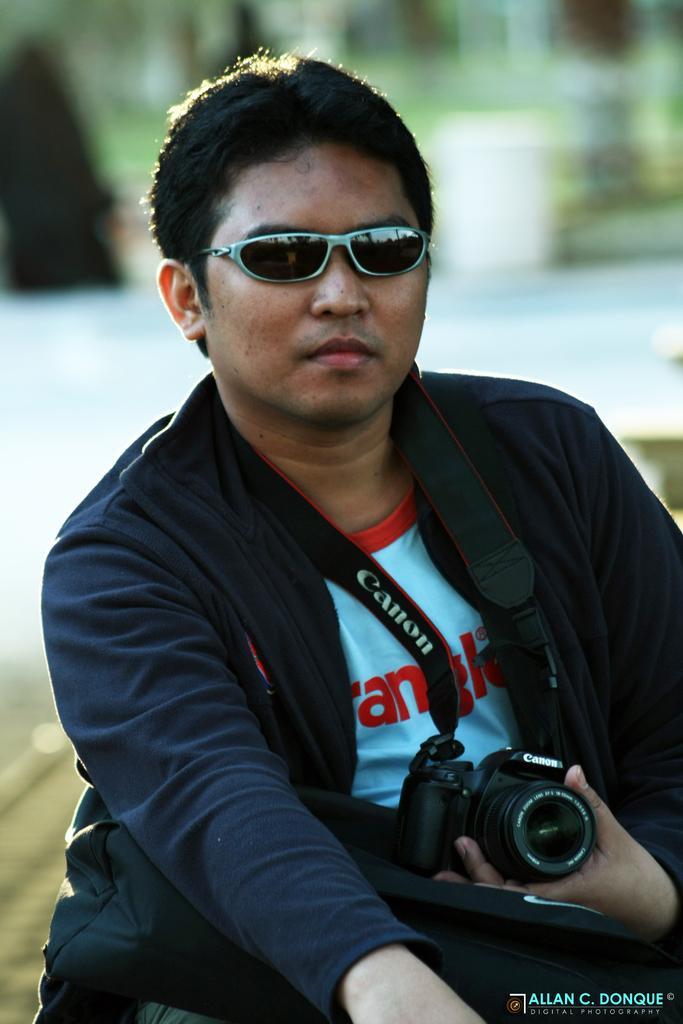How would you summarize this image in a sentence or two? In this image there is a person wearing black color jacket and goggles holding a camera in his hands. 